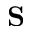<formula> <loc_0><loc_0><loc_500><loc_500>S</formula> 